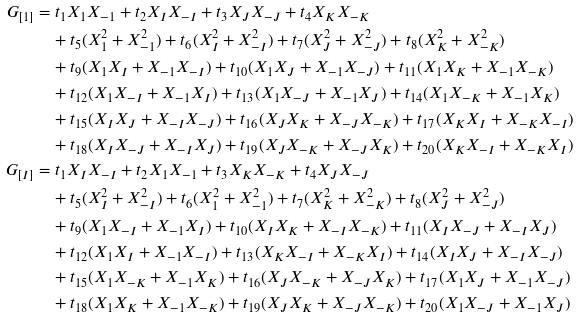<formula> <loc_0><loc_0><loc_500><loc_500>G _ { [ 1 ] } & = t _ { 1 } X _ { 1 } X _ { - 1 } + t _ { 2 } X _ { I } X _ { - I } + t _ { 3 } X _ { J } X _ { - J } + t _ { 4 } X _ { K } X _ { - K } \\ & \quad + t _ { 5 } ( X _ { 1 } ^ { 2 } + X _ { - 1 } ^ { 2 } ) + t _ { 6 } ( X _ { I } ^ { 2 } + X _ { - I } ^ { 2 } ) + t _ { 7 } ( X _ { J } ^ { 2 } + X _ { - J } ^ { 2 } ) + t _ { 8 } ( X _ { K } ^ { 2 } + X _ { - K } ^ { 2 } ) \\ & \quad + t _ { 9 } ( X _ { 1 } X _ { I } + X _ { - 1 } X _ { - I } ) + t _ { 1 0 } ( X _ { 1 } X _ { J } + X _ { - 1 } X _ { - J } ) + t _ { 1 1 } ( X _ { 1 } X _ { K } + X _ { - 1 } X _ { - K } ) \\ & \quad + t _ { 1 2 } ( X _ { 1 } X _ { - I } + X _ { - 1 } X _ { I } ) + t _ { 1 3 } ( X _ { 1 } X _ { - J } + X _ { - 1 } X _ { J } ) + t _ { 1 4 } ( X _ { 1 } X _ { - K } + X _ { - 1 } X _ { K } ) \\ & \quad + t _ { 1 5 } ( X _ { I } X _ { J } + X _ { - I } X _ { - J } ) + t _ { 1 6 } ( X _ { J } X _ { K } + X _ { - J } X _ { - K } ) + t _ { 1 7 } ( X _ { K } X _ { I } + X _ { - K } X _ { - I } ) \\ & \quad + t _ { 1 8 } ( X _ { I } X _ { - J } + X _ { - I } X _ { J } ) + t _ { 1 9 } ( X _ { J } X _ { - K } + X _ { - J } X _ { K } ) + t _ { 2 0 } ( X _ { K } X _ { - I } + X _ { - K } X _ { I } ) \\ G _ { [ I ] } & = t _ { 1 } X _ { I } X _ { - I } + t _ { 2 } X _ { 1 } X _ { - 1 } + t _ { 3 } X _ { K } X _ { - K } + t _ { 4 } X _ { J } X _ { - J } \\ & \quad + t _ { 5 } ( X _ { I } ^ { 2 } + X _ { - I } ^ { 2 } ) + t _ { 6 } ( X _ { 1 } ^ { 2 } + X _ { - 1 } ^ { 2 } ) + t _ { 7 } ( X _ { K } ^ { 2 } + X _ { - K } ^ { 2 } ) + t _ { 8 } ( X _ { J } ^ { 2 } + X _ { - J } ^ { 2 } ) \\ & \quad + t _ { 9 } ( X _ { 1 } X _ { - I } + X _ { - 1 } X _ { I } ) + t _ { 1 0 } ( X _ { I } X _ { K } + X _ { - I } X _ { - K } ) + t _ { 1 1 } ( X _ { I } X _ { - J } + X _ { - I } X _ { J } ) \\ & \quad + t _ { 1 2 } ( X _ { 1 } X _ { I } + X _ { - 1 } X _ { - I } ) + t _ { 1 3 } ( X _ { K } X _ { - I } + X _ { - K } X _ { I } ) + t _ { 1 4 } ( X _ { I } X _ { J } + X _ { - I } X _ { - J } ) \\ & \quad + t _ { 1 5 } ( X _ { 1 } X _ { - K } + X _ { - 1 } X _ { K } ) + t _ { 1 6 } ( X _ { J } X _ { - K } + X _ { - J } X _ { K } ) + t _ { 1 7 } ( X _ { 1 } X _ { J } + X _ { - 1 } X _ { - J } ) \\ & \quad + t _ { 1 8 } ( X _ { 1 } X _ { K } + X _ { - 1 } X _ { - K } ) + t _ { 1 9 } ( X _ { J } X _ { K } + X _ { - J } X _ { - K } ) + t _ { 2 0 } ( X _ { 1 } X _ { - J } + X _ { - 1 } X _ { J } )</formula> 